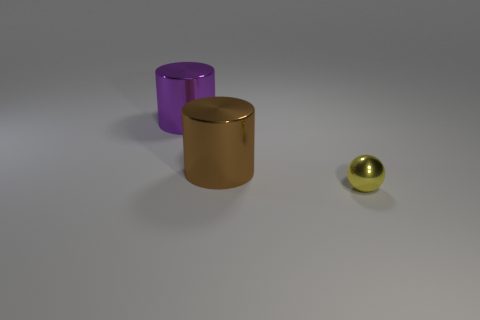Add 3 yellow metal balls. How many objects exist? 6 Subtract all cylinders. How many objects are left? 1 Subtract 0 red cylinders. How many objects are left? 3 Subtract all small yellow things. Subtract all small gray matte balls. How many objects are left? 2 Add 3 big purple objects. How many big purple objects are left? 4 Add 3 tiny purple spheres. How many tiny purple spheres exist? 3 